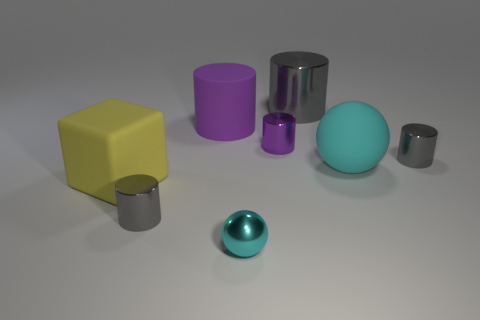What number of small metallic cylinders are the same color as the large block?
Give a very brief answer. 0. The purple object that is the same material as the small ball is what size?
Your answer should be very brief. Small. What shape is the tiny gray metal object that is on the right side of the big purple cylinder?
Offer a terse response. Cylinder. There is another purple object that is the same shape as the purple matte object; what size is it?
Keep it short and to the point. Small. There is a sphere to the right of the gray metallic cylinder that is behind the small purple metal cylinder; what number of purple matte things are behind it?
Your response must be concise. 1. Are there an equal number of purple cylinders right of the yellow rubber block and big cyan rubber cubes?
Your response must be concise. No. What number of balls are either big shiny things or yellow rubber objects?
Your answer should be compact. 0. Does the tiny shiny sphere have the same color as the big sphere?
Keep it short and to the point. Yes. Is the number of big gray cylinders that are in front of the tiny purple metal cylinder the same as the number of yellow cubes that are on the right side of the big metal object?
Your answer should be very brief. Yes. What is the color of the big matte block?
Keep it short and to the point. Yellow. 